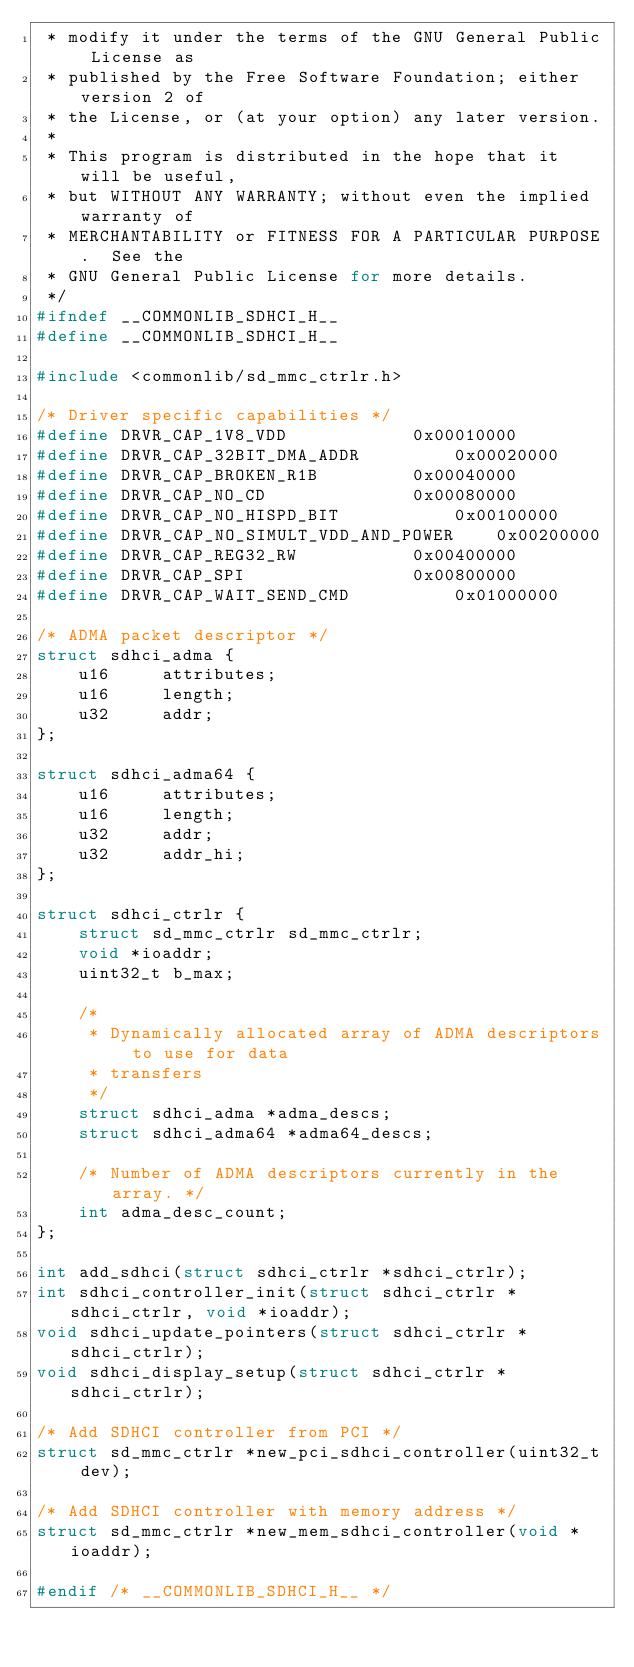<code> <loc_0><loc_0><loc_500><loc_500><_C_> * modify it under the terms of the GNU General Public License as
 * published by the Free Software Foundation; either version 2 of
 * the License, or (at your option) any later version.
 *
 * This program is distributed in the hope that it will be useful,
 * but WITHOUT ANY WARRANTY; without even the implied warranty of
 * MERCHANTABILITY or FITNESS FOR A PARTICULAR PURPOSE.  See the
 * GNU General Public License for more details.
 */
#ifndef __COMMONLIB_SDHCI_H__
#define __COMMONLIB_SDHCI_H__

#include <commonlib/sd_mmc_ctrlr.h>

/* Driver specific capabilities */
#define DRVR_CAP_1V8_VDD			0x00010000
#define DRVR_CAP_32BIT_DMA_ADDR			0x00020000
#define DRVR_CAP_BROKEN_R1B			0x00040000
#define DRVR_CAP_NO_CD				0x00080000
#define DRVR_CAP_NO_HISPD_BIT			0x00100000
#define DRVR_CAP_NO_SIMULT_VDD_AND_POWER	0x00200000
#define DRVR_CAP_REG32_RW			0x00400000
#define DRVR_CAP_SPI				0x00800000
#define DRVR_CAP_WAIT_SEND_CMD			0x01000000

/* ADMA packet descriptor */
struct sdhci_adma {
	u16     attributes;
	u16     length;
	u32     addr;
};

struct sdhci_adma64 {
	u16     attributes;
	u16     length;
	u32     addr;
	u32     addr_hi;
};

struct sdhci_ctrlr {
	struct sd_mmc_ctrlr sd_mmc_ctrlr;
	void *ioaddr;
	uint32_t b_max;

	/*
	 * Dynamically allocated array of ADMA descriptors to use for data
	 * transfers
	 */
	struct sdhci_adma *adma_descs;
	struct sdhci_adma64 *adma64_descs;

	/* Number of ADMA descriptors currently in the array. */
	int adma_desc_count;
};

int add_sdhci(struct sdhci_ctrlr *sdhci_ctrlr);
int sdhci_controller_init(struct sdhci_ctrlr *sdhci_ctrlr, void *ioaddr);
void sdhci_update_pointers(struct sdhci_ctrlr *sdhci_ctrlr);
void sdhci_display_setup(struct sdhci_ctrlr *sdhci_ctrlr);

/* Add SDHCI controller from PCI */
struct sd_mmc_ctrlr *new_pci_sdhci_controller(uint32_t dev);

/* Add SDHCI controller with memory address */
struct sd_mmc_ctrlr *new_mem_sdhci_controller(void *ioaddr);

#endif /* __COMMONLIB_SDHCI_H__ */
</code> 